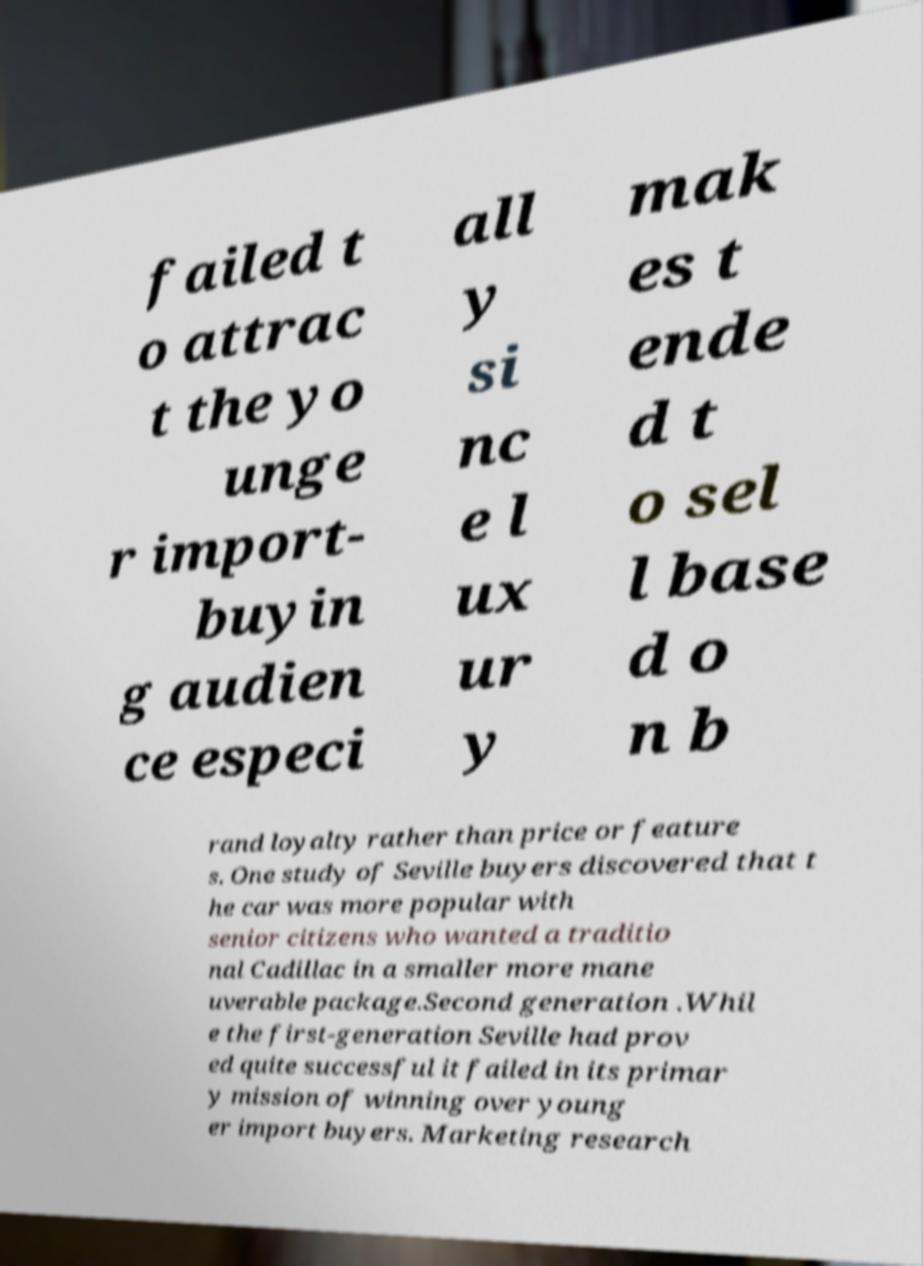For documentation purposes, I need the text within this image transcribed. Could you provide that? failed t o attrac t the yo unge r import- buyin g audien ce especi all y si nc e l ux ur y mak es t ende d t o sel l base d o n b rand loyalty rather than price or feature s. One study of Seville buyers discovered that t he car was more popular with senior citizens who wanted a traditio nal Cadillac in a smaller more mane uverable package.Second generation .Whil e the first-generation Seville had prov ed quite successful it failed in its primar y mission of winning over young er import buyers. Marketing research 